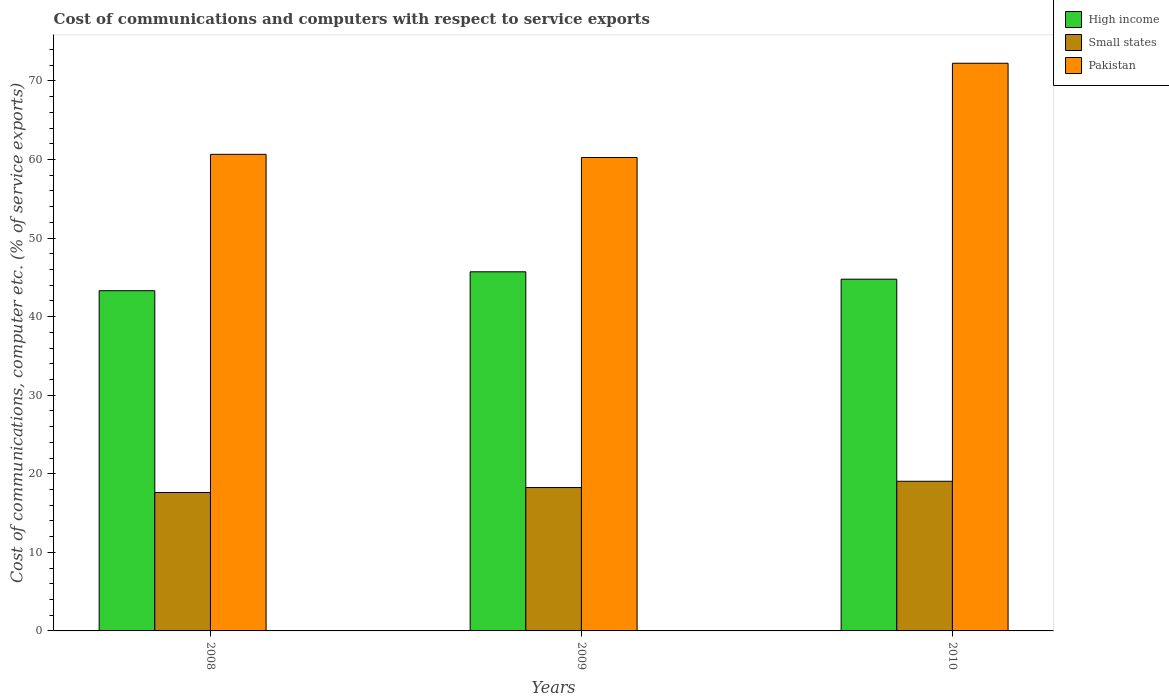How many different coloured bars are there?
Make the answer very short. 3. How many groups of bars are there?
Your answer should be very brief. 3. Are the number of bars per tick equal to the number of legend labels?
Keep it short and to the point. Yes. How many bars are there on the 2nd tick from the left?
Give a very brief answer. 3. What is the label of the 3rd group of bars from the left?
Offer a very short reply. 2010. What is the cost of communications and computers in High income in 2010?
Ensure brevity in your answer.  44.76. Across all years, what is the maximum cost of communications and computers in Pakistan?
Keep it short and to the point. 72.24. Across all years, what is the minimum cost of communications and computers in Pakistan?
Your response must be concise. 60.25. What is the total cost of communications and computers in Pakistan in the graph?
Give a very brief answer. 193.15. What is the difference between the cost of communications and computers in Pakistan in 2008 and that in 2010?
Make the answer very short. -11.59. What is the difference between the cost of communications and computers in High income in 2008 and the cost of communications and computers in Small states in 2009?
Give a very brief answer. 25.05. What is the average cost of communications and computers in High income per year?
Offer a terse response. 44.59. In the year 2009, what is the difference between the cost of communications and computers in Small states and cost of communications and computers in High income?
Ensure brevity in your answer.  -27.45. What is the ratio of the cost of communications and computers in Pakistan in 2009 to that in 2010?
Your answer should be compact. 0.83. Is the cost of communications and computers in High income in 2009 less than that in 2010?
Give a very brief answer. No. Is the difference between the cost of communications and computers in Small states in 2008 and 2010 greater than the difference between the cost of communications and computers in High income in 2008 and 2010?
Keep it short and to the point. Yes. What is the difference between the highest and the second highest cost of communications and computers in High income?
Offer a very short reply. 0.94. What is the difference between the highest and the lowest cost of communications and computers in Small states?
Offer a terse response. 1.43. Is the sum of the cost of communications and computers in Small states in 2009 and 2010 greater than the maximum cost of communications and computers in Pakistan across all years?
Make the answer very short. No. What does the 2nd bar from the left in 2008 represents?
Give a very brief answer. Small states. What does the 2nd bar from the right in 2009 represents?
Offer a terse response. Small states. How many bars are there?
Offer a very short reply. 9. Are all the bars in the graph horizontal?
Your answer should be very brief. No. Does the graph contain any zero values?
Make the answer very short. No. Does the graph contain grids?
Your answer should be compact. No. Where does the legend appear in the graph?
Provide a succinct answer. Top right. How many legend labels are there?
Your answer should be compact. 3. How are the legend labels stacked?
Ensure brevity in your answer.  Vertical. What is the title of the graph?
Provide a succinct answer. Cost of communications and computers with respect to service exports. Does "Central African Republic" appear as one of the legend labels in the graph?
Ensure brevity in your answer.  No. What is the label or title of the Y-axis?
Your response must be concise. Cost of communications, computer etc. (% of service exports). What is the Cost of communications, computer etc. (% of service exports) of High income in 2008?
Provide a short and direct response. 43.3. What is the Cost of communications, computer etc. (% of service exports) of Small states in 2008?
Give a very brief answer. 17.62. What is the Cost of communications, computer etc. (% of service exports) of Pakistan in 2008?
Your answer should be very brief. 60.65. What is the Cost of communications, computer etc. (% of service exports) in High income in 2009?
Your answer should be compact. 45.7. What is the Cost of communications, computer etc. (% of service exports) of Small states in 2009?
Your answer should be compact. 18.25. What is the Cost of communications, computer etc. (% of service exports) of Pakistan in 2009?
Provide a succinct answer. 60.25. What is the Cost of communications, computer etc. (% of service exports) in High income in 2010?
Offer a terse response. 44.76. What is the Cost of communications, computer etc. (% of service exports) of Small states in 2010?
Ensure brevity in your answer.  19.05. What is the Cost of communications, computer etc. (% of service exports) in Pakistan in 2010?
Keep it short and to the point. 72.24. Across all years, what is the maximum Cost of communications, computer etc. (% of service exports) of High income?
Provide a succinct answer. 45.7. Across all years, what is the maximum Cost of communications, computer etc. (% of service exports) in Small states?
Your answer should be compact. 19.05. Across all years, what is the maximum Cost of communications, computer etc. (% of service exports) of Pakistan?
Offer a terse response. 72.24. Across all years, what is the minimum Cost of communications, computer etc. (% of service exports) of High income?
Provide a short and direct response. 43.3. Across all years, what is the minimum Cost of communications, computer etc. (% of service exports) of Small states?
Give a very brief answer. 17.62. Across all years, what is the minimum Cost of communications, computer etc. (% of service exports) of Pakistan?
Offer a very short reply. 60.25. What is the total Cost of communications, computer etc. (% of service exports) in High income in the graph?
Your response must be concise. 133.76. What is the total Cost of communications, computer etc. (% of service exports) in Small states in the graph?
Offer a very short reply. 54.91. What is the total Cost of communications, computer etc. (% of service exports) of Pakistan in the graph?
Provide a succinct answer. 193.15. What is the difference between the Cost of communications, computer etc. (% of service exports) in High income in 2008 and that in 2009?
Provide a short and direct response. -2.41. What is the difference between the Cost of communications, computer etc. (% of service exports) of Small states in 2008 and that in 2009?
Your answer should be compact. -0.63. What is the difference between the Cost of communications, computer etc. (% of service exports) of Pakistan in 2008 and that in 2009?
Provide a succinct answer. 0.41. What is the difference between the Cost of communications, computer etc. (% of service exports) of High income in 2008 and that in 2010?
Provide a succinct answer. -1.47. What is the difference between the Cost of communications, computer etc. (% of service exports) of Small states in 2008 and that in 2010?
Provide a succinct answer. -1.43. What is the difference between the Cost of communications, computer etc. (% of service exports) in Pakistan in 2008 and that in 2010?
Your response must be concise. -11.59. What is the difference between the Cost of communications, computer etc. (% of service exports) of High income in 2009 and that in 2010?
Your answer should be very brief. 0.94. What is the difference between the Cost of communications, computer etc. (% of service exports) in Small states in 2009 and that in 2010?
Keep it short and to the point. -0.8. What is the difference between the Cost of communications, computer etc. (% of service exports) in Pakistan in 2009 and that in 2010?
Your answer should be very brief. -12. What is the difference between the Cost of communications, computer etc. (% of service exports) in High income in 2008 and the Cost of communications, computer etc. (% of service exports) in Small states in 2009?
Your answer should be very brief. 25.05. What is the difference between the Cost of communications, computer etc. (% of service exports) of High income in 2008 and the Cost of communications, computer etc. (% of service exports) of Pakistan in 2009?
Offer a very short reply. -16.95. What is the difference between the Cost of communications, computer etc. (% of service exports) in Small states in 2008 and the Cost of communications, computer etc. (% of service exports) in Pakistan in 2009?
Give a very brief answer. -42.63. What is the difference between the Cost of communications, computer etc. (% of service exports) in High income in 2008 and the Cost of communications, computer etc. (% of service exports) in Small states in 2010?
Offer a terse response. 24.25. What is the difference between the Cost of communications, computer etc. (% of service exports) in High income in 2008 and the Cost of communications, computer etc. (% of service exports) in Pakistan in 2010?
Provide a short and direct response. -28.95. What is the difference between the Cost of communications, computer etc. (% of service exports) in Small states in 2008 and the Cost of communications, computer etc. (% of service exports) in Pakistan in 2010?
Offer a very short reply. -54.63. What is the difference between the Cost of communications, computer etc. (% of service exports) in High income in 2009 and the Cost of communications, computer etc. (% of service exports) in Small states in 2010?
Offer a terse response. 26.66. What is the difference between the Cost of communications, computer etc. (% of service exports) of High income in 2009 and the Cost of communications, computer etc. (% of service exports) of Pakistan in 2010?
Ensure brevity in your answer.  -26.54. What is the difference between the Cost of communications, computer etc. (% of service exports) in Small states in 2009 and the Cost of communications, computer etc. (% of service exports) in Pakistan in 2010?
Your response must be concise. -53.99. What is the average Cost of communications, computer etc. (% of service exports) of High income per year?
Give a very brief answer. 44.59. What is the average Cost of communications, computer etc. (% of service exports) of Small states per year?
Your answer should be very brief. 18.3. What is the average Cost of communications, computer etc. (% of service exports) of Pakistan per year?
Keep it short and to the point. 64.38. In the year 2008, what is the difference between the Cost of communications, computer etc. (% of service exports) of High income and Cost of communications, computer etc. (% of service exports) of Small states?
Provide a succinct answer. 25.68. In the year 2008, what is the difference between the Cost of communications, computer etc. (% of service exports) of High income and Cost of communications, computer etc. (% of service exports) of Pakistan?
Provide a succinct answer. -17.36. In the year 2008, what is the difference between the Cost of communications, computer etc. (% of service exports) of Small states and Cost of communications, computer etc. (% of service exports) of Pakistan?
Ensure brevity in your answer.  -43.04. In the year 2009, what is the difference between the Cost of communications, computer etc. (% of service exports) in High income and Cost of communications, computer etc. (% of service exports) in Small states?
Provide a succinct answer. 27.45. In the year 2009, what is the difference between the Cost of communications, computer etc. (% of service exports) of High income and Cost of communications, computer etc. (% of service exports) of Pakistan?
Offer a very short reply. -14.55. In the year 2009, what is the difference between the Cost of communications, computer etc. (% of service exports) of Small states and Cost of communications, computer etc. (% of service exports) of Pakistan?
Keep it short and to the point. -42. In the year 2010, what is the difference between the Cost of communications, computer etc. (% of service exports) of High income and Cost of communications, computer etc. (% of service exports) of Small states?
Your response must be concise. 25.72. In the year 2010, what is the difference between the Cost of communications, computer etc. (% of service exports) in High income and Cost of communications, computer etc. (% of service exports) in Pakistan?
Your response must be concise. -27.48. In the year 2010, what is the difference between the Cost of communications, computer etc. (% of service exports) in Small states and Cost of communications, computer etc. (% of service exports) in Pakistan?
Provide a succinct answer. -53.2. What is the ratio of the Cost of communications, computer etc. (% of service exports) of High income in 2008 to that in 2009?
Keep it short and to the point. 0.95. What is the ratio of the Cost of communications, computer etc. (% of service exports) of Small states in 2008 to that in 2009?
Offer a terse response. 0.97. What is the ratio of the Cost of communications, computer etc. (% of service exports) in Pakistan in 2008 to that in 2009?
Make the answer very short. 1.01. What is the ratio of the Cost of communications, computer etc. (% of service exports) of High income in 2008 to that in 2010?
Your response must be concise. 0.97. What is the ratio of the Cost of communications, computer etc. (% of service exports) of Small states in 2008 to that in 2010?
Your answer should be very brief. 0.93. What is the ratio of the Cost of communications, computer etc. (% of service exports) in Pakistan in 2008 to that in 2010?
Your response must be concise. 0.84. What is the ratio of the Cost of communications, computer etc. (% of service exports) of Small states in 2009 to that in 2010?
Provide a short and direct response. 0.96. What is the ratio of the Cost of communications, computer etc. (% of service exports) of Pakistan in 2009 to that in 2010?
Provide a short and direct response. 0.83. What is the difference between the highest and the second highest Cost of communications, computer etc. (% of service exports) in High income?
Provide a succinct answer. 0.94. What is the difference between the highest and the second highest Cost of communications, computer etc. (% of service exports) in Small states?
Ensure brevity in your answer.  0.8. What is the difference between the highest and the second highest Cost of communications, computer etc. (% of service exports) of Pakistan?
Provide a short and direct response. 11.59. What is the difference between the highest and the lowest Cost of communications, computer etc. (% of service exports) of High income?
Provide a short and direct response. 2.41. What is the difference between the highest and the lowest Cost of communications, computer etc. (% of service exports) in Small states?
Ensure brevity in your answer.  1.43. What is the difference between the highest and the lowest Cost of communications, computer etc. (% of service exports) of Pakistan?
Your response must be concise. 12. 